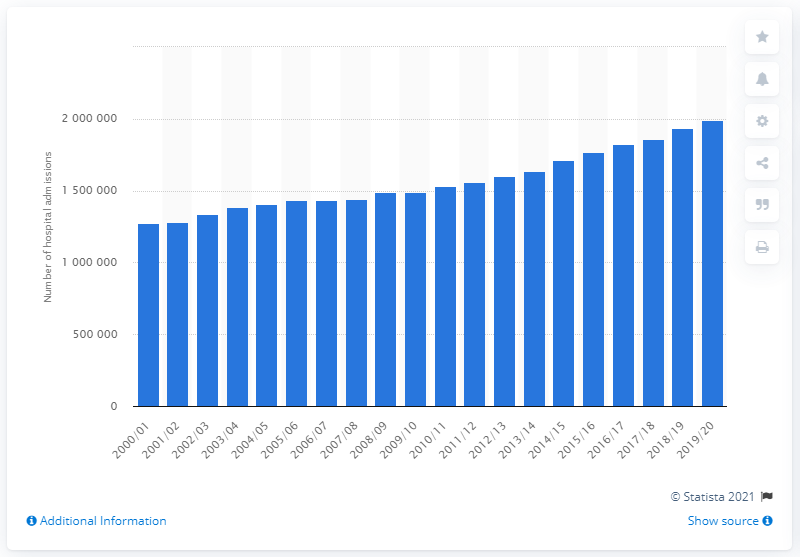Mention a couple of crucial points in this snapshot. In the year 2000/01, a total of 128,347 adults in England were admitted to the hospital due to smoking. In the year 2019/20, there were 199,118 hospital admissions in the United Kingdom that were attributed to smoking, according to official statistics. 